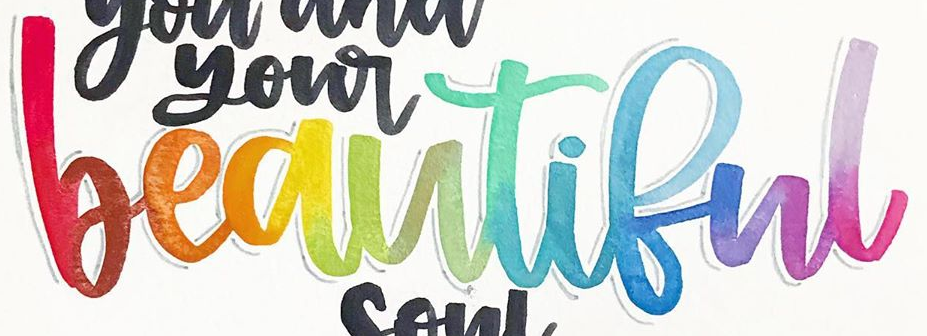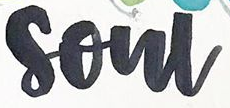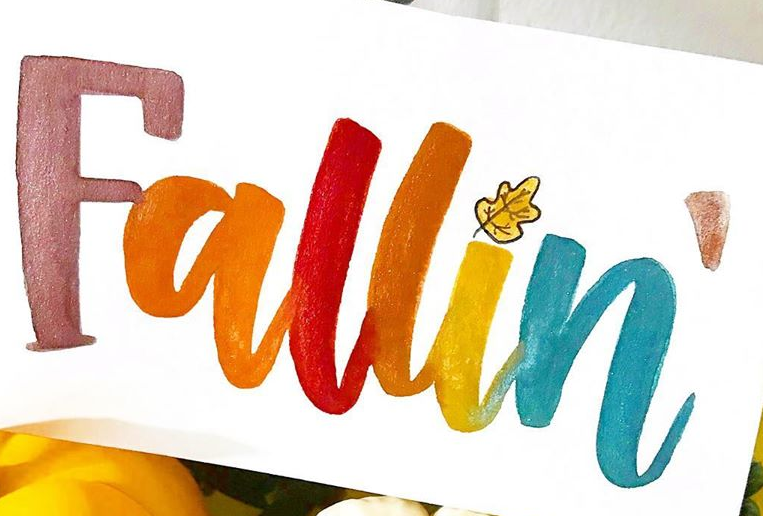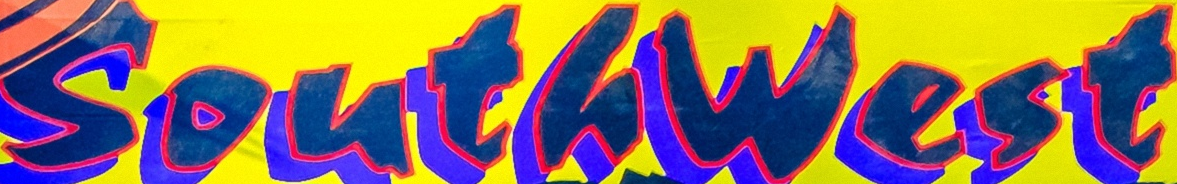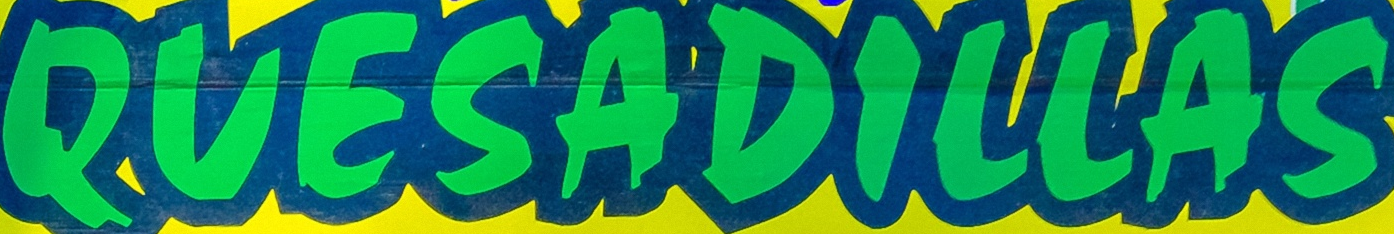What words are shown in these images in order, separated by a semicolon? beautiful; soul; Fallin; Southwest; QUESADILLAS 